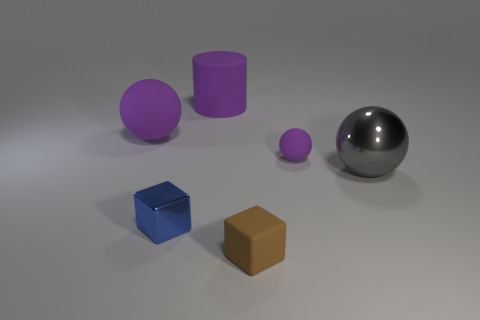What number of objects are either large purple spheres or big green metallic objects?
Offer a very short reply. 1. Are there any brown cubes made of the same material as the large purple cylinder?
Make the answer very short. Yes. There is another matte ball that is the same color as the small rubber ball; what size is it?
Offer a very short reply. Large. There is a large object in front of the purple rubber thing right of the rubber block; what color is it?
Provide a short and direct response. Gray. Is the size of the cylinder the same as the metallic block?
Keep it short and to the point. No. How many cylinders are either big purple rubber objects or brown things?
Provide a short and direct response. 1. What number of rubber blocks are behind the purple sphere that is left of the small blue cube?
Provide a short and direct response. 0. Do the gray shiny object and the small blue metallic object have the same shape?
Ensure brevity in your answer.  No. There is a brown thing that is the same shape as the tiny blue thing; what is its size?
Your response must be concise. Small. There is a big purple thing behind the rubber ball that is to the left of the tiny purple ball; what shape is it?
Give a very brief answer. Cylinder. 